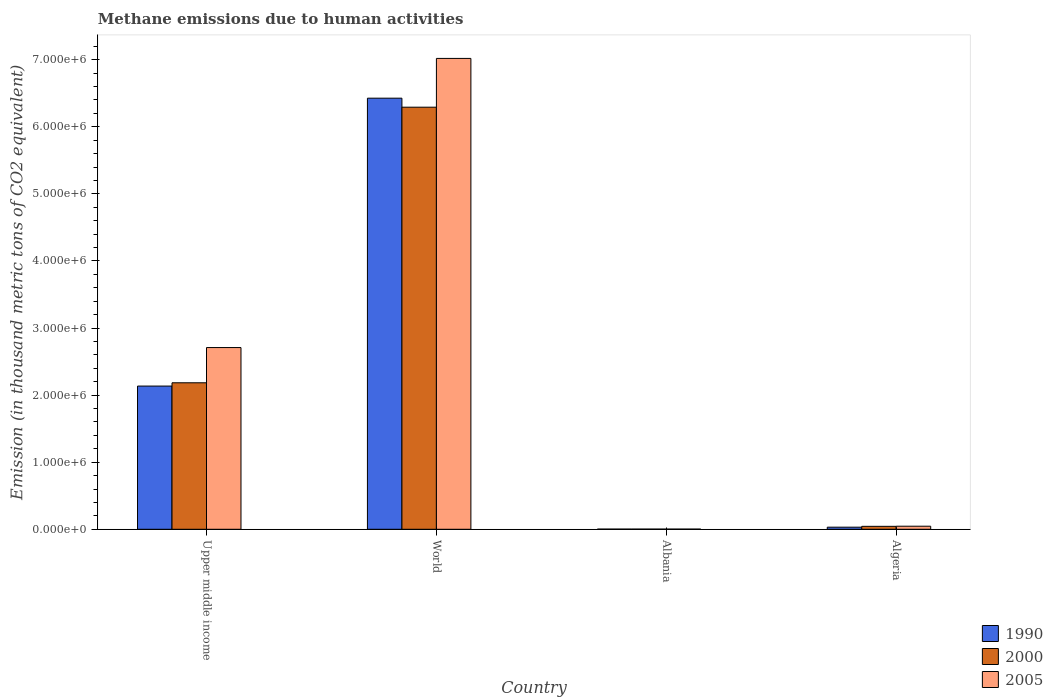How many different coloured bars are there?
Ensure brevity in your answer.  3. Are the number of bars per tick equal to the number of legend labels?
Ensure brevity in your answer.  Yes. How many bars are there on the 2nd tick from the left?
Keep it short and to the point. 3. How many bars are there on the 1st tick from the right?
Provide a succinct answer. 3. What is the label of the 3rd group of bars from the left?
Keep it short and to the point. Albania. In how many cases, is the number of bars for a given country not equal to the number of legend labels?
Ensure brevity in your answer.  0. What is the amount of methane emitted in 2000 in Algeria?
Provide a succinct answer. 4.38e+04. Across all countries, what is the maximum amount of methane emitted in 2005?
Keep it short and to the point. 7.02e+06. Across all countries, what is the minimum amount of methane emitted in 1990?
Offer a very short reply. 2542.8. In which country was the amount of methane emitted in 2000 maximum?
Keep it short and to the point. World. In which country was the amount of methane emitted in 1990 minimum?
Make the answer very short. Albania. What is the total amount of methane emitted in 2000 in the graph?
Offer a terse response. 8.52e+06. What is the difference between the amount of methane emitted in 2000 in Albania and that in Upper middle income?
Keep it short and to the point. -2.18e+06. What is the difference between the amount of methane emitted in 2005 in Albania and the amount of methane emitted in 2000 in World?
Your answer should be very brief. -6.29e+06. What is the average amount of methane emitted in 2000 per country?
Provide a succinct answer. 2.13e+06. What is the difference between the amount of methane emitted of/in 2005 and amount of methane emitted of/in 1990 in Algeria?
Make the answer very short. 1.44e+04. What is the ratio of the amount of methane emitted in 2000 in Albania to that in World?
Offer a terse response. 0. What is the difference between the highest and the second highest amount of methane emitted in 2000?
Keep it short and to the point. 6.25e+06. What is the difference between the highest and the lowest amount of methane emitted in 2000?
Your answer should be compact. 6.29e+06. What does the 3rd bar from the right in World represents?
Provide a succinct answer. 1990. Is it the case that in every country, the sum of the amount of methane emitted in 2000 and amount of methane emitted in 1990 is greater than the amount of methane emitted in 2005?
Provide a succinct answer. Yes. How many bars are there?
Provide a succinct answer. 12. How many countries are there in the graph?
Offer a very short reply. 4. What is the difference between two consecutive major ticks on the Y-axis?
Make the answer very short. 1.00e+06. Does the graph contain any zero values?
Offer a terse response. No. Where does the legend appear in the graph?
Your answer should be very brief. Bottom right. How many legend labels are there?
Your response must be concise. 3. How are the legend labels stacked?
Your response must be concise. Vertical. What is the title of the graph?
Keep it short and to the point. Methane emissions due to human activities. Does "1982" appear as one of the legend labels in the graph?
Ensure brevity in your answer.  No. What is the label or title of the Y-axis?
Your response must be concise. Emission (in thousand metric tons of CO2 equivalent). What is the Emission (in thousand metric tons of CO2 equivalent) of 1990 in Upper middle income?
Keep it short and to the point. 2.13e+06. What is the Emission (in thousand metric tons of CO2 equivalent) of 2000 in Upper middle income?
Offer a very short reply. 2.18e+06. What is the Emission (in thousand metric tons of CO2 equivalent) of 2005 in Upper middle income?
Provide a short and direct response. 2.71e+06. What is the Emission (in thousand metric tons of CO2 equivalent) of 1990 in World?
Give a very brief answer. 6.43e+06. What is the Emission (in thousand metric tons of CO2 equivalent) in 2000 in World?
Your answer should be very brief. 6.29e+06. What is the Emission (in thousand metric tons of CO2 equivalent) of 2005 in World?
Provide a succinct answer. 7.02e+06. What is the Emission (in thousand metric tons of CO2 equivalent) in 1990 in Albania?
Make the answer very short. 2542.8. What is the Emission (in thousand metric tons of CO2 equivalent) of 2000 in Albania?
Ensure brevity in your answer.  2608.4. What is the Emission (in thousand metric tons of CO2 equivalent) in 2005 in Albania?
Offer a very short reply. 2477.1. What is the Emission (in thousand metric tons of CO2 equivalent) in 1990 in Algeria?
Offer a very short reply. 3.12e+04. What is the Emission (in thousand metric tons of CO2 equivalent) of 2000 in Algeria?
Provide a short and direct response. 4.38e+04. What is the Emission (in thousand metric tons of CO2 equivalent) in 2005 in Algeria?
Make the answer very short. 4.56e+04. Across all countries, what is the maximum Emission (in thousand metric tons of CO2 equivalent) in 1990?
Provide a short and direct response. 6.43e+06. Across all countries, what is the maximum Emission (in thousand metric tons of CO2 equivalent) of 2000?
Provide a short and direct response. 6.29e+06. Across all countries, what is the maximum Emission (in thousand metric tons of CO2 equivalent) in 2005?
Ensure brevity in your answer.  7.02e+06. Across all countries, what is the minimum Emission (in thousand metric tons of CO2 equivalent) of 1990?
Your response must be concise. 2542.8. Across all countries, what is the minimum Emission (in thousand metric tons of CO2 equivalent) of 2000?
Your answer should be compact. 2608.4. Across all countries, what is the minimum Emission (in thousand metric tons of CO2 equivalent) in 2005?
Your answer should be compact. 2477.1. What is the total Emission (in thousand metric tons of CO2 equivalent) of 1990 in the graph?
Make the answer very short. 8.60e+06. What is the total Emission (in thousand metric tons of CO2 equivalent) of 2000 in the graph?
Your response must be concise. 8.52e+06. What is the total Emission (in thousand metric tons of CO2 equivalent) of 2005 in the graph?
Your response must be concise. 9.78e+06. What is the difference between the Emission (in thousand metric tons of CO2 equivalent) in 1990 in Upper middle income and that in World?
Offer a terse response. -4.29e+06. What is the difference between the Emission (in thousand metric tons of CO2 equivalent) in 2000 in Upper middle income and that in World?
Your answer should be very brief. -4.11e+06. What is the difference between the Emission (in thousand metric tons of CO2 equivalent) of 2005 in Upper middle income and that in World?
Offer a terse response. -4.31e+06. What is the difference between the Emission (in thousand metric tons of CO2 equivalent) in 1990 in Upper middle income and that in Albania?
Provide a succinct answer. 2.13e+06. What is the difference between the Emission (in thousand metric tons of CO2 equivalent) in 2000 in Upper middle income and that in Albania?
Give a very brief answer. 2.18e+06. What is the difference between the Emission (in thousand metric tons of CO2 equivalent) in 2005 in Upper middle income and that in Albania?
Provide a short and direct response. 2.71e+06. What is the difference between the Emission (in thousand metric tons of CO2 equivalent) of 1990 in Upper middle income and that in Algeria?
Keep it short and to the point. 2.10e+06. What is the difference between the Emission (in thousand metric tons of CO2 equivalent) in 2000 in Upper middle income and that in Algeria?
Provide a short and direct response. 2.14e+06. What is the difference between the Emission (in thousand metric tons of CO2 equivalent) of 2005 in Upper middle income and that in Algeria?
Provide a succinct answer. 2.66e+06. What is the difference between the Emission (in thousand metric tons of CO2 equivalent) of 1990 in World and that in Albania?
Make the answer very short. 6.42e+06. What is the difference between the Emission (in thousand metric tons of CO2 equivalent) in 2000 in World and that in Albania?
Offer a terse response. 6.29e+06. What is the difference between the Emission (in thousand metric tons of CO2 equivalent) of 2005 in World and that in Albania?
Offer a very short reply. 7.02e+06. What is the difference between the Emission (in thousand metric tons of CO2 equivalent) of 1990 in World and that in Algeria?
Offer a terse response. 6.40e+06. What is the difference between the Emission (in thousand metric tons of CO2 equivalent) in 2000 in World and that in Algeria?
Your response must be concise. 6.25e+06. What is the difference between the Emission (in thousand metric tons of CO2 equivalent) of 2005 in World and that in Algeria?
Your response must be concise. 6.97e+06. What is the difference between the Emission (in thousand metric tons of CO2 equivalent) in 1990 in Albania and that in Algeria?
Your response must be concise. -2.87e+04. What is the difference between the Emission (in thousand metric tons of CO2 equivalent) in 2000 in Albania and that in Algeria?
Your answer should be compact. -4.12e+04. What is the difference between the Emission (in thousand metric tons of CO2 equivalent) in 2005 in Albania and that in Algeria?
Provide a short and direct response. -4.31e+04. What is the difference between the Emission (in thousand metric tons of CO2 equivalent) of 1990 in Upper middle income and the Emission (in thousand metric tons of CO2 equivalent) of 2000 in World?
Your answer should be very brief. -4.16e+06. What is the difference between the Emission (in thousand metric tons of CO2 equivalent) in 1990 in Upper middle income and the Emission (in thousand metric tons of CO2 equivalent) in 2005 in World?
Provide a succinct answer. -4.88e+06. What is the difference between the Emission (in thousand metric tons of CO2 equivalent) in 2000 in Upper middle income and the Emission (in thousand metric tons of CO2 equivalent) in 2005 in World?
Keep it short and to the point. -4.84e+06. What is the difference between the Emission (in thousand metric tons of CO2 equivalent) of 1990 in Upper middle income and the Emission (in thousand metric tons of CO2 equivalent) of 2000 in Albania?
Your answer should be compact. 2.13e+06. What is the difference between the Emission (in thousand metric tons of CO2 equivalent) in 1990 in Upper middle income and the Emission (in thousand metric tons of CO2 equivalent) in 2005 in Albania?
Provide a succinct answer. 2.13e+06. What is the difference between the Emission (in thousand metric tons of CO2 equivalent) of 2000 in Upper middle income and the Emission (in thousand metric tons of CO2 equivalent) of 2005 in Albania?
Make the answer very short. 2.18e+06. What is the difference between the Emission (in thousand metric tons of CO2 equivalent) in 1990 in Upper middle income and the Emission (in thousand metric tons of CO2 equivalent) in 2000 in Algeria?
Keep it short and to the point. 2.09e+06. What is the difference between the Emission (in thousand metric tons of CO2 equivalent) of 1990 in Upper middle income and the Emission (in thousand metric tons of CO2 equivalent) of 2005 in Algeria?
Make the answer very short. 2.09e+06. What is the difference between the Emission (in thousand metric tons of CO2 equivalent) of 2000 in Upper middle income and the Emission (in thousand metric tons of CO2 equivalent) of 2005 in Algeria?
Offer a terse response. 2.14e+06. What is the difference between the Emission (in thousand metric tons of CO2 equivalent) in 1990 in World and the Emission (in thousand metric tons of CO2 equivalent) in 2000 in Albania?
Provide a succinct answer. 6.42e+06. What is the difference between the Emission (in thousand metric tons of CO2 equivalent) of 1990 in World and the Emission (in thousand metric tons of CO2 equivalent) of 2005 in Albania?
Make the answer very short. 6.42e+06. What is the difference between the Emission (in thousand metric tons of CO2 equivalent) in 2000 in World and the Emission (in thousand metric tons of CO2 equivalent) in 2005 in Albania?
Provide a succinct answer. 6.29e+06. What is the difference between the Emission (in thousand metric tons of CO2 equivalent) in 1990 in World and the Emission (in thousand metric tons of CO2 equivalent) in 2000 in Algeria?
Give a very brief answer. 6.38e+06. What is the difference between the Emission (in thousand metric tons of CO2 equivalent) in 1990 in World and the Emission (in thousand metric tons of CO2 equivalent) in 2005 in Algeria?
Make the answer very short. 6.38e+06. What is the difference between the Emission (in thousand metric tons of CO2 equivalent) in 2000 in World and the Emission (in thousand metric tons of CO2 equivalent) in 2005 in Algeria?
Provide a short and direct response. 6.25e+06. What is the difference between the Emission (in thousand metric tons of CO2 equivalent) of 1990 in Albania and the Emission (in thousand metric tons of CO2 equivalent) of 2000 in Algeria?
Keep it short and to the point. -4.13e+04. What is the difference between the Emission (in thousand metric tons of CO2 equivalent) of 1990 in Albania and the Emission (in thousand metric tons of CO2 equivalent) of 2005 in Algeria?
Offer a very short reply. -4.31e+04. What is the difference between the Emission (in thousand metric tons of CO2 equivalent) of 2000 in Albania and the Emission (in thousand metric tons of CO2 equivalent) of 2005 in Algeria?
Make the answer very short. -4.30e+04. What is the average Emission (in thousand metric tons of CO2 equivalent) of 1990 per country?
Offer a terse response. 2.15e+06. What is the average Emission (in thousand metric tons of CO2 equivalent) in 2000 per country?
Give a very brief answer. 2.13e+06. What is the average Emission (in thousand metric tons of CO2 equivalent) of 2005 per country?
Your answer should be very brief. 2.44e+06. What is the difference between the Emission (in thousand metric tons of CO2 equivalent) in 1990 and Emission (in thousand metric tons of CO2 equivalent) in 2000 in Upper middle income?
Offer a very short reply. -4.89e+04. What is the difference between the Emission (in thousand metric tons of CO2 equivalent) in 1990 and Emission (in thousand metric tons of CO2 equivalent) in 2005 in Upper middle income?
Your answer should be compact. -5.74e+05. What is the difference between the Emission (in thousand metric tons of CO2 equivalent) of 2000 and Emission (in thousand metric tons of CO2 equivalent) of 2005 in Upper middle income?
Your response must be concise. -5.25e+05. What is the difference between the Emission (in thousand metric tons of CO2 equivalent) in 1990 and Emission (in thousand metric tons of CO2 equivalent) in 2000 in World?
Your response must be concise. 1.34e+05. What is the difference between the Emission (in thousand metric tons of CO2 equivalent) of 1990 and Emission (in thousand metric tons of CO2 equivalent) of 2005 in World?
Your answer should be compact. -5.93e+05. What is the difference between the Emission (in thousand metric tons of CO2 equivalent) of 2000 and Emission (in thousand metric tons of CO2 equivalent) of 2005 in World?
Provide a short and direct response. -7.27e+05. What is the difference between the Emission (in thousand metric tons of CO2 equivalent) in 1990 and Emission (in thousand metric tons of CO2 equivalent) in 2000 in Albania?
Provide a succinct answer. -65.6. What is the difference between the Emission (in thousand metric tons of CO2 equivalent) in 1990 and Emission (in thousand metric tons of CO2 equivalent) in 2005 in Albania?
Your answer should be very brief. 65.7. What is the difference between the Emission (in thousand metric tons of CO2 equivalent) in 2000 and Emission (in thousand metric tons of CO2 equivalent) in 2005 in Albania?
Ensure brevity in your answer.  131.3. What is the difference between the Emission (in thousand metric tons of CO2 equivalent) of 1990 and Emission (in thousand metric tons of CO2 equivalent) of 2000 in Algeria?
Your response must be concise. -1.26e+04. What is the difference between the Emission (in thousand metric tons of CO2 equivalent) of 1990 and Emission (in thousand metric tons of CO2 equivalent) of 2005 in Algeria?
Offer a terse response. -1.44e+04. What is the difference between the Emission (in thousand metric tons of CO2 equivalent) of 2000 and Emission (in thousand metric tons of CO2 equivalent) of 2005 in Algeria?
Keep it short and to the point. -1815.4. What is the ratio of the Emission (in thousand metric tons of CO2 equivalent) in 1990 in Upper middle income to that in World?
Offer a terse response. 0.33. What is the ratio of the Emission (in thousand metric tons of CO2 equivalent) in 2000 in Upper middle income to that in World?
Give a very brief answer. 0.35. What is the ratio of the Emission (in thousand metric tons of CO2 equivalent) in 2005 in Upper middle income to that in World?
Keep it short and to the point. 0.39. What is the ratio of the Emission (in thousand metric tons of CO2 equivalent) in 1990 in Upper middle income to that in Albania?
Your answer should be very brief. 839.58. What is the ratio of the Emission (in thousand metric tons of CO2 equivalent) of 2000 in Upper middle income to that in Albania?
Your answer should be compact. 837.21. What is the ratio of the Emission (in thousand metric tons of CO2 equivalent) of 2005 in Upper middle income to that in Albania?
Your answer should be compact. 1093.59. What is the ratio of the Emission (in thousand metric tons of CO2 equivalent) of 1990 in Upper middle income to that in Algeria?
Your answer should be very brief. 68.4. What is the ratio of the Emission (in thousand metric tons of CO2 equivalent) of 2000 in Upper middle income to that in Algeria?
Make the answer very short. 49.86. What is the ratio of the Emission (in thousand metric tons of CO2 equivalent) in 2005 in Upper middle income to that in Algeria?
Ensure brevity in your answer.  59.39. What is the ratio of the Emission (in thousand metric tons of CO2 equivalent) in 1990 in World to that in Albania?
Offer a terse response. 2527.36. What is the ratio of the Emission (in thousand metric tons of CO2 equivalent) in 2000 in World to that in Albania?
Ensure brevity in your answer.  2412.32. What is the ratio of the Emission (in thousand metric tons of CO2 equivalent) in 2005 in World to that in Albania?
Your answer should be very brief. 2833.71. What is the ratio of the Emission (in thousand metric tons of CO2 equivalent) in 1990 in World to that in Algeria?
Keep it short and to the point. 205.9. What is the ratio of the Emission (in thousand metric tons of CO2 equivalent) in 2000 in World to that in Algeria?
Your response must be concise. 143.67. What is the ratio of the Emission (in thousand metric tons of CO2 equivalent) in 2005 in World to that in Algeria?
Offer a very short reply. 153.89. What is the ratio of the Emission (in thousand metric tons of CO2 equivalent) in 1990 in Albania to that in Algeria?
Offer a terse response. 0.08. What is the ratio of the Emission (in thousand metric tons of CO2 equivalent) of 2000 in Albania to that in Algeria?
Ensure brevity in your answer.  0.06. What is the ratio of the Emission (in thousand metric tons of CO2 equivalent) in 2005 in Albania to that in Algeria?
Keep it short and to the point. 0.05. What is the difference between the highest and the second highest Emission (in thousand metric tons of CO2 equivalent) in 1990?
Make the answer very short. 4.29e+06. What is the difference between the highest and the second highest Emission (in thousand metric tons of CO2 equivalent) in 2000?
Make the answer very short. 4.11e+06. What is the difference between the highest and the second highest Emission (in thousand metric tons of CO2 equivalent) of 2005?
Offer a terse response. 4.31e+06. What is the difference between the highest and the lowest Emission (in thousand metric tons of CO2 equivalent) of 1990?
Provide a short and direct response. 6.42e+06. What is the difference between the highest and the lowest Emission (in thousand metric tons of CO2 equivalent) in 2000?
Offer a terse response. 6.29e+06. What is the difference between the highest and the lowest Emission (in thousand metric tons of CO2 equivalent) in 2005?
Ensure brevity in your answer.  7.02e+06. 